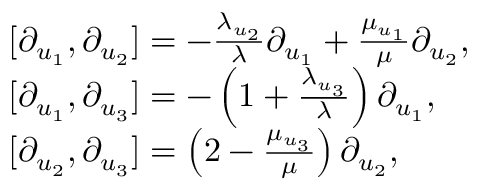Convert formula to latex. <formula><loc_0><loc_0><loc_500><loc_500>\begin{array} { r l } & { [ \partial _ { u _ { 1 } } , \partial _ { u _ { 2 } } ] = - \frac { \lambda _ { u _ { 2 } } } { \lambda } \partial _ { u _ { 1 } } + \frac { \mu _ { u _ { 1 } } } { \mu } \partial _ { u _ { 2 } } , } \\ & { [ \partial _ { u _ { 1 } } , \partial _ { u _ { 3 } } ] = - \left ( 1 + \frac { \lambda _ { u _ { 3 } } } { \lambda } \right ) \partial _ { u _ { 1 } } , } \\ & { [ \partial _ { u _ { 2 } } , \partial _ { u _ { 3 } } ] = \left ( 2 - \frac { \mu _ { u _ { 3 } } } { \mu } \right ) \partial _ { u _ { 2 } } , } \end{array}</formula> 